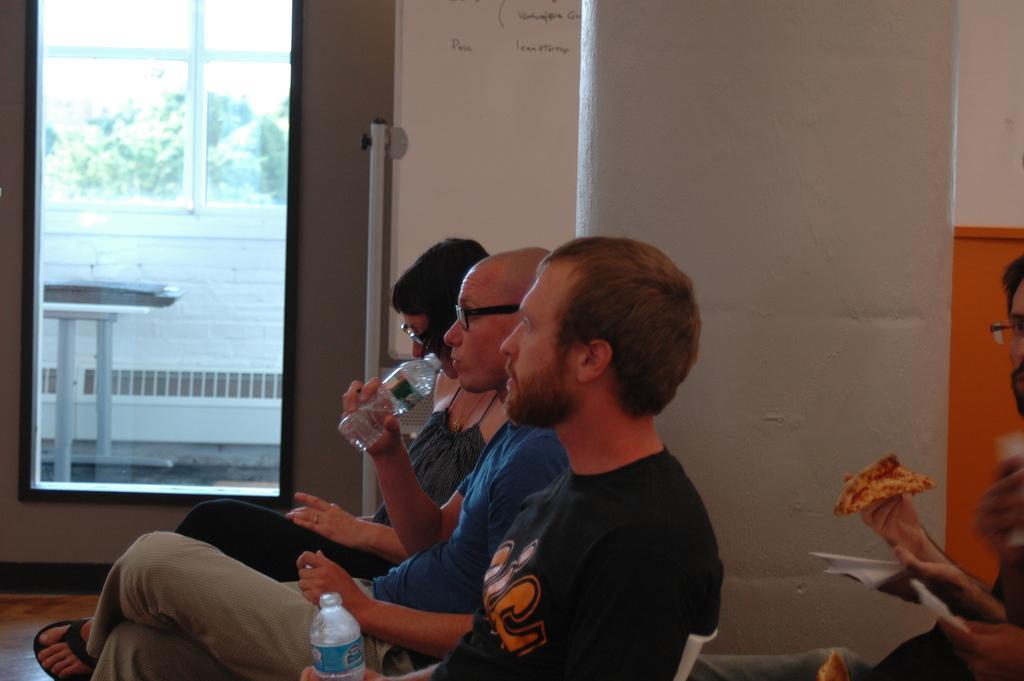Can you describe this image briefly? In this picture we can see three persons sitting on chairs, these two men are holding water bottles, in the background there is a wall, we can see a door here, from the glass we can see trees, a person on the right side is holding a piece of pizza. 